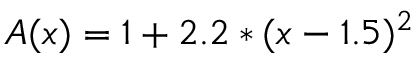Convert formula to latex. <formula><loc_0><loc_0><loc_500><loc_500>A ( x ) = 1 + 2 . 2 * ( x - 1 . 5 ) ^ { 2 }</formula> 